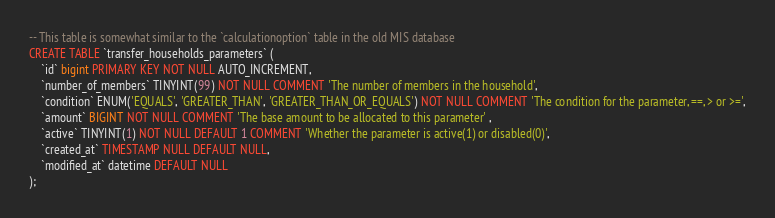Convert code to text. <code><loc_0><loc_0><loc_500><loc_500><_SQL_>-- This table is somewhat similar to the `calculationoption` table in the old MIS database
CREATE TABLE `transfer_households_parameters` (
    `id` bigint PRIMARY KEY NOT NULL AUTO_INCREMENT,
    `number_of_members` TINYINT(99) NOT NULL COMMENT 'The number of members in the household',
    `condition` ENUM('EQUALS', 'GREATER_THAN', 'GREATER_THAN_OR_EQUALS') NOT NULL COMMENT 'The condition for the parameter, ==, > or >=',
    `amount` BIGINT NOT NULL COMMENT 'The base amount to be allocated to this parameter' ,
    `active` TINYINT(1) NOT NULL DEFAULT 1 COMMENT 'Whether the parameter is active(1) or disabled(0)',
	`created_at` TIMESTAMP NULL DEFAULT NULL,
	`modified_at` datetime DEFAULT NULL
);
</code> 